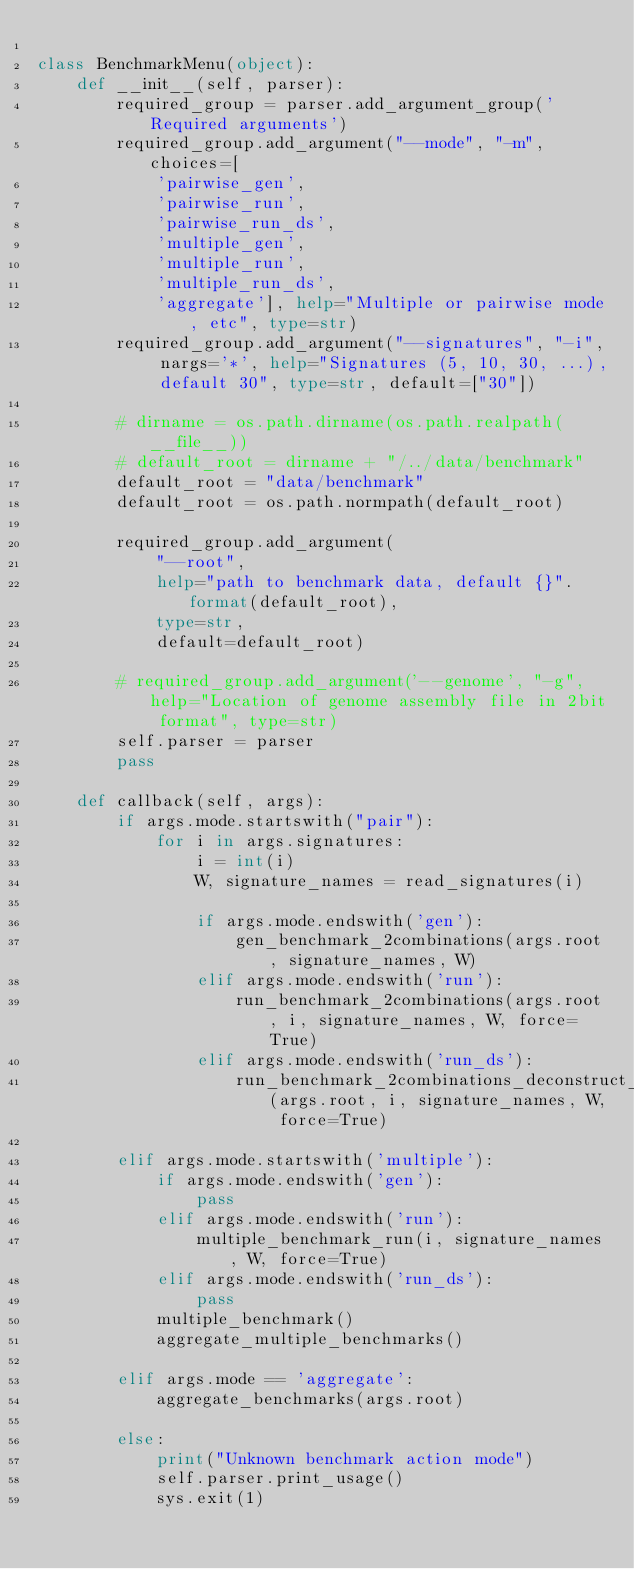<code> <loc_0><loc_0><loc_500><loc_500><_Python_>
class BenchmarkMenu(object):
    def __init__(self, parser):
        required_group = parser.add_argument_group('Required arguments')
        required_group.add_argument("--mode", "-m", choices=[
            'pairwise_gen',
            'pairwise_run',
            'pairwise_run_ds',
            'multiple_gen',
            'multiple_run',
            'multiple_run_ds',
            'aggregate'], help="Multiple or pairwise mode, etc", type=str)
        required_group.add_argument("--signatures", "-i", nargs='*', help="Signatures (5, 10, 30, ...), default 30", type=str, default=["30"])

        # dirname = os.path.dirname(os.path.realpath(__file__))
        # default_root = dirname + "/../data/benchmark"
        default_root = "data/benchmark"
        default_root = os.path.normpath(default_root)

        required_group.add_argument(
            "--root",
            help="path to benchmark data, default {}".format(default_root),
            type=str,
            default=default_root)

        # required_group.add_argument('--genome', "-g", help="Location of genome assembly file in 2bit format", type=str)
        self.parser = parser
        pass

    def callback(self, args):
        if args.mode.startswith("pair"):
            for i in args.signatures:
                i = int(i)
                W, signature_names = read_signatures(i)

                if args.mode.endswith('gen'):
                    gen_benchmark_2combinations(args.root, signature_names, W)
                elif args.mode.endswith('run'):
                    run_benchmark_2combinations(args.root, i, signature_names, W, force=True)
                elif args.mode.endswith('run_ds'):
                    run_benchmark_2combinations_deconstruct_sigs(args.root, i, signature_names, W, force=True)

        elif args.mode.startswith('multiple'):
            if args.mode.endswith('gen'):
                pass
            elif args.mode.endswith('run'):
                multiple_benchmark_run(i, signature_names, W, force=True)
            elif args.mode.endswith('run_ds'):
                pass
            multiple_benchmark()
            aggregate_multiple_benchmarks()

        elif args.mode == 'aggregate':
            aggregate_benchmarks(args.root)

        else:
            print("Unknown benchmark action mode")
            self.parser.print_usage()
            sys.exit(1)
</code> 